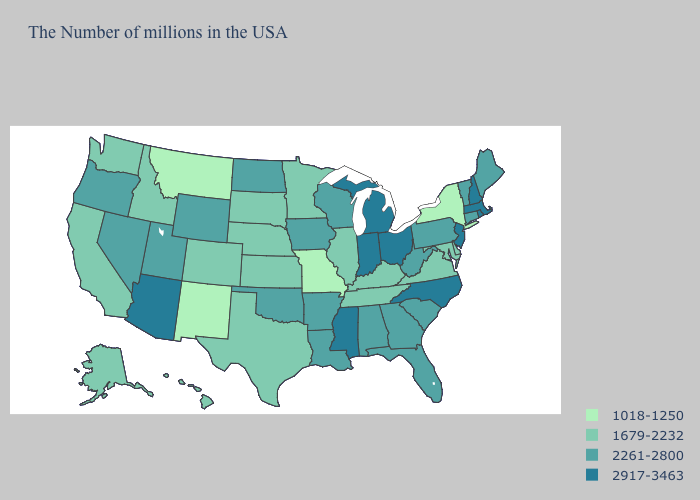What is the value of New York?
Quick response, please. 1018-1250. Does Illinois have the lowest value in the USA?
Short answer required. No. Does the first symbol in the legend represent the smallest category?
Answer briefly. Yes. Does Arizona have a lower value than Idaho?
Answer briefly. No. What is the value of Iowa?
Be succinct. 2261-2800. Among the states that border Georgia , does South Carolina have the highest value?
Write a very short answer. No. Name the states that have a value in the range 1018-1250?
Quick response, please. New York, Missouri, New Mexico, Montana. What is the highest value in the USA?
Short answer required. 2917-3463. Which states have the lowest value in the USA?
Quick response, please. New York, Missouri, New Mexico, Montana. Is the legend a continuous bar?
Quick response, please. No. What is the highest value in states that border Nebraska?
Write a very short answer. 2261-2800. Name the states that have a value in the range 2917-3463?
Answer briefly. Massachusetts, Rhode Island, New Hampshire, New Jersey, North Carolina, Ohio, Michigan, Indiana, Mississippi, Arizona. Which states have the lowest value in the West?
Short answer required. New Mexico, Montana. What is the value of Georgia?
Keep it brief. 2261-2800. What is the lowest value in states that border Arkansas?
Quick response, please. 1018-1250. 